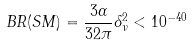Convert formula to latex. <formula><loc_0><loc_0><loc_500><loc_500>B R ( S M ) = \frac { 3 \alpha } { 3 2 \pi } \delta _ { \nu } ^ { 2 } < 1 0 ^ { - 4 0 }</formula> 